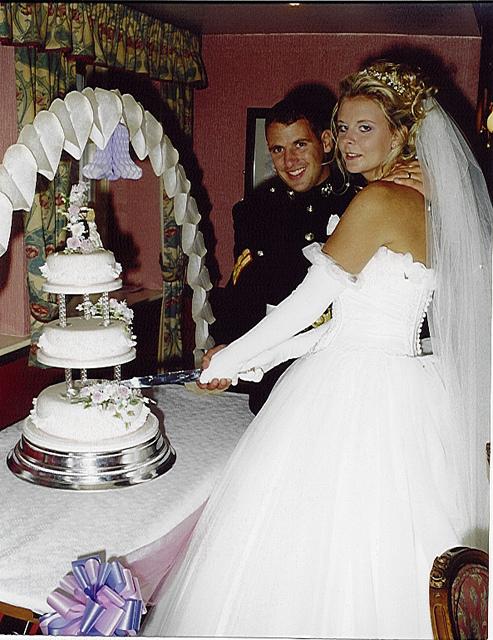What is the couple celebrating?
Write a very short answer. Wedding. What color is the cake?
Answer briefly. White. Is the bride young?
Be succinct. Yes. 